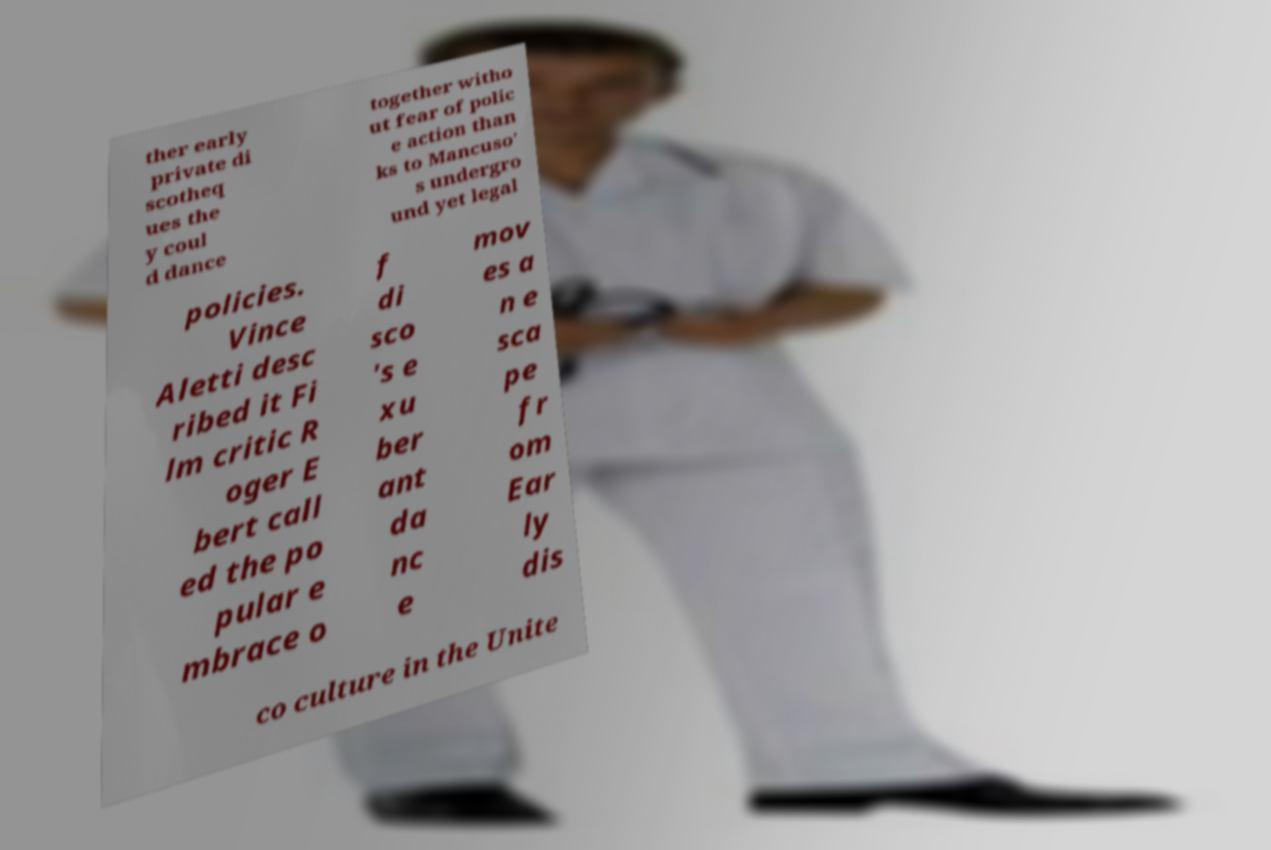Please identify and transcribe the text found in this image. ther early private di scotheq ues the y coul d dance together witho ut fear of polic e action than ks to Mancuso' s undergro und yet legal policies. Vince Aletti desc ribed it Fi lm critic R oger E bert call ed the po pular e mbrace o f di sco 's e xu ber ant da nc e mov es a n e sca pe fr om Ear ly dis co culture in the Unite 